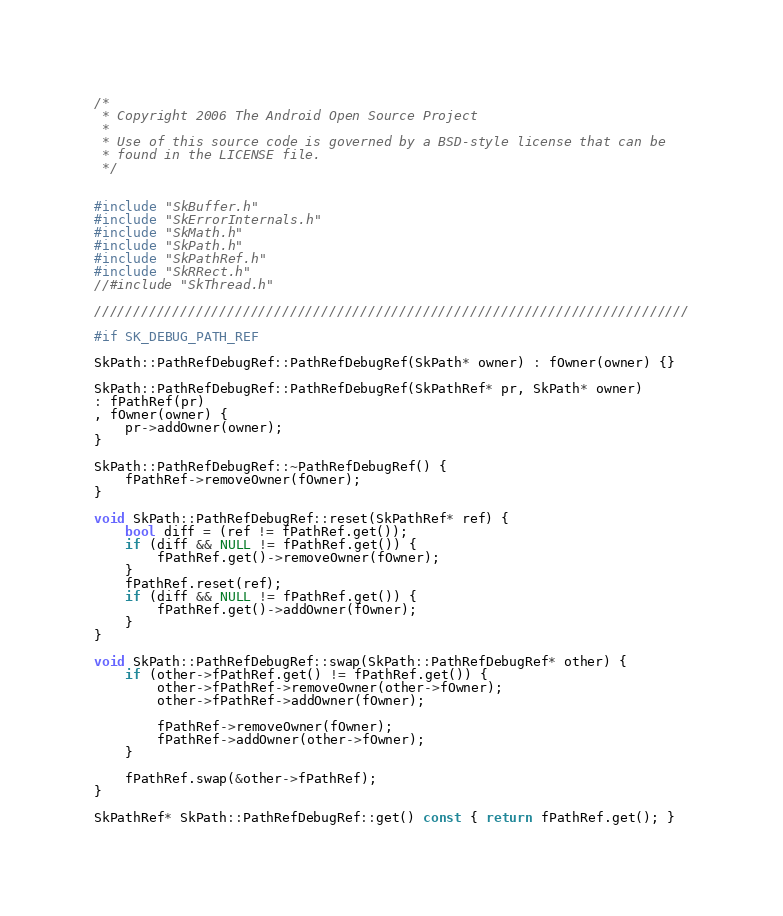<code> <loc_0><loc_0><loc_500><loc_500><_C++_>
/*
 * Copyright 2006 The Android Open Source Project
 *
 * Use of this source code is governed by a BSD-style license that can be
 * found in the LICENSE file.
 */


#include "SkBuffer.h"
#include "SkErrorInternals.h"
#include "SkMath.h"
#include "SkPath.h"
#include "SkPathRef.h"
#include "SkRRect.h"
//#include "SkThread.h"

////////////////////////////////////////////////////////////////////////////

#if SK_DEBUG_PATH_REF

SkPath::PathRefDebugRef::PathRefDebugRef(SkPath* owner) : fOwner(owner) {}

SkPath::PathRefDebugRef::PathRefDebugRef(SkPathRef* pr, SkPath* owner)
: fPathRef(pr)
, fOwner(owner) {
    pr->addOwner(owner);
}

SkPath::PathRefDebugRef::~PathRefDebugRef() {
    fPathRef->removeOwner(fOwner);
}

void SkPath::PathRefDebugRef::reset(SkPathRef* ref) {
    bool diff = (ref != fPathRef.get());
    if (diff && NULL != fPathRef.get()) {
        fPathRef.get()->removeOwner(fOwner);
    }
    fPathRef.reset(ref);
    if (diff && NULL != fPathRef.get()) {
        fPathRef.get()->addOwner(fOwner);
    }
}

void SkPath::PathRefDebugRef::swap(SkPath::PathRefDebugRef* other) {
    if (other->fPathRef.get() != fPathRef.get()) {
        other->fPathRef->removeOwner(other->fOwner);
        other->fPathRef->addOwner(fOwner);

        fPathRef->removeOwner(fOwner);
        fPathRef->addOwner(other->fOwner);
    }

    fPathRef.swap(&other->fPathRef);
}

SkPathRef* SkPath::PathRefDebugRef::get() const { return fPathRef.get(); }
</code> 